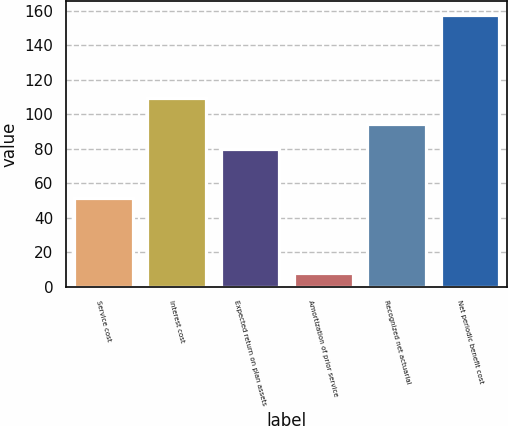Convert chart. <chart><loc_0><loc_0><loc_500><loc_500><bar_chart><fcel>Service cost<fcel>Interest cost<fcel>Expected return on plan assets<fcel>Amortization of prior service<fcel>Recognized net actuarial<fcel>Net periodic benefit cost<nl><fcel>51.4<fcel>109.48<fcel>79.5<fcel>7.7<fcel>94.49<fcel>157.6<nl></chart> 